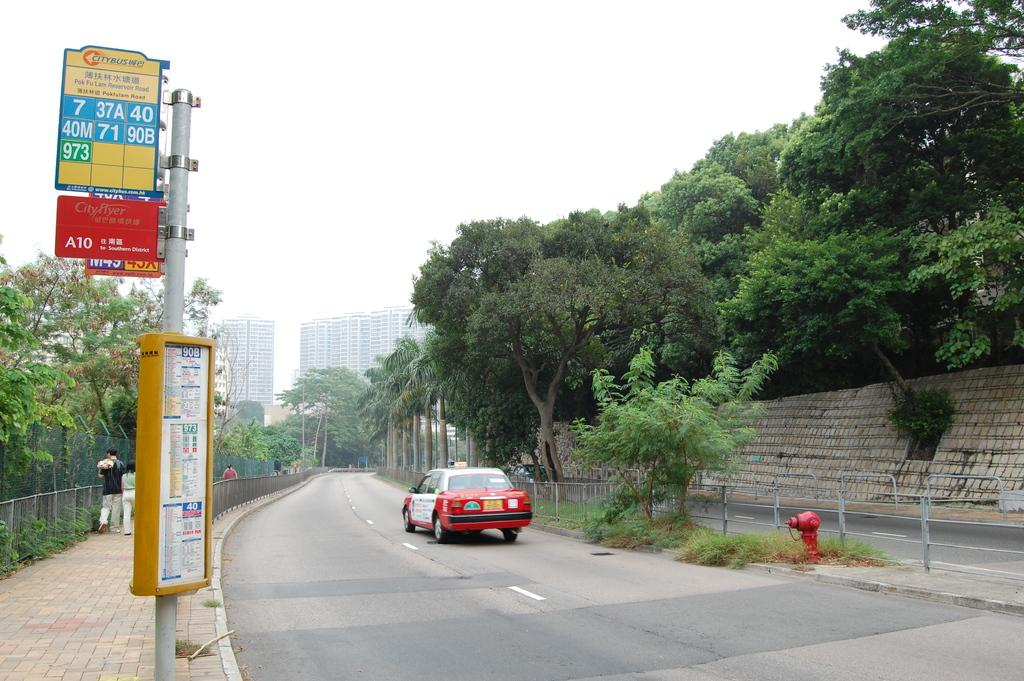<image>
Present a compact description of the photo's key features. A bus stop for Citybus that notes seven different routes. 